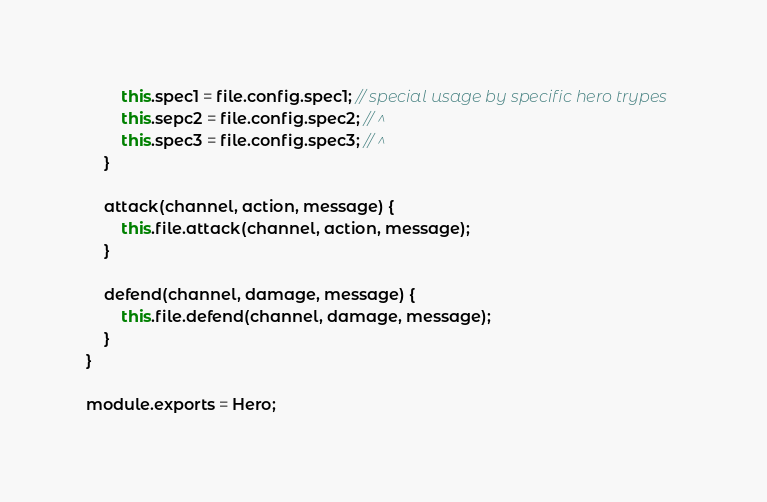Convert code to text. <code><loc_0><loc_0><loc_500><loc_500><_JavaScript_>        this.spec1 = file.config.spec1; // special usage by specific hero trypes
        this.sepc2 = file.config.spec2; // ^
        this.spec3 = file.config.spec3; // ^
    }
    
    attack(channel, action, message) {
    	this.file.attack(channel, action, message);
    }
    
    defend(channel, damage, message) {
    	this.file.defend(channel, damage, message);
    }
}

module.exports = Hero;</code> 